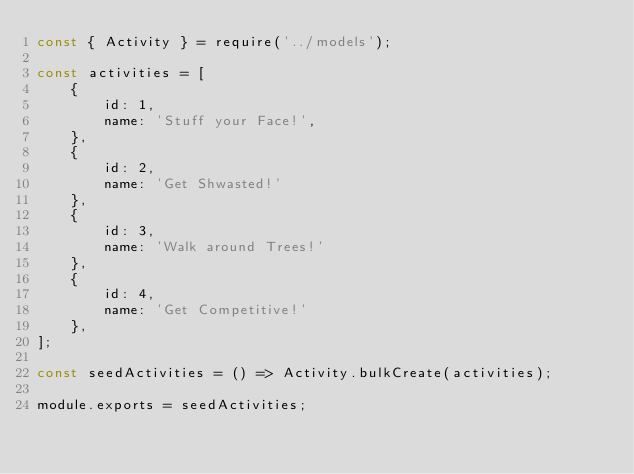<code> <loc_0><loc_0><loc_500><loc_500><_JavaScript_>const { Activity } = require('../models');

const activities = [
    {
        id: 1,
        name: 'Stuff your Face!',
    },
    {
        id: 2,
        name: 'Get Shwasted!'
    },
    {
        id: 3,
        name: 'Walk around Trees!'
    },
    {
        id: 4,
        name: 'Get Competitive!'
    },
];

const seedActivities = () => Activity.bulkCreate(activities);

module.exports = seedActivities;</code> 